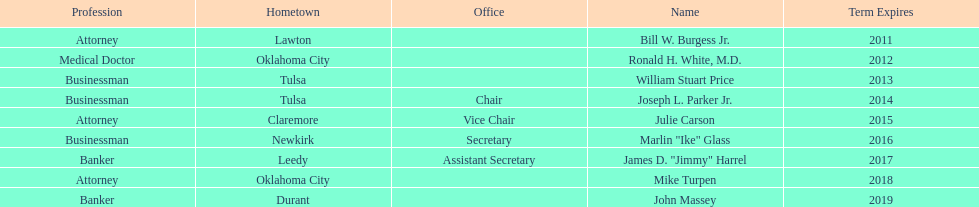Other members of the state regents from tulsa besides joseph l. parker jr. William Stuart Price. 